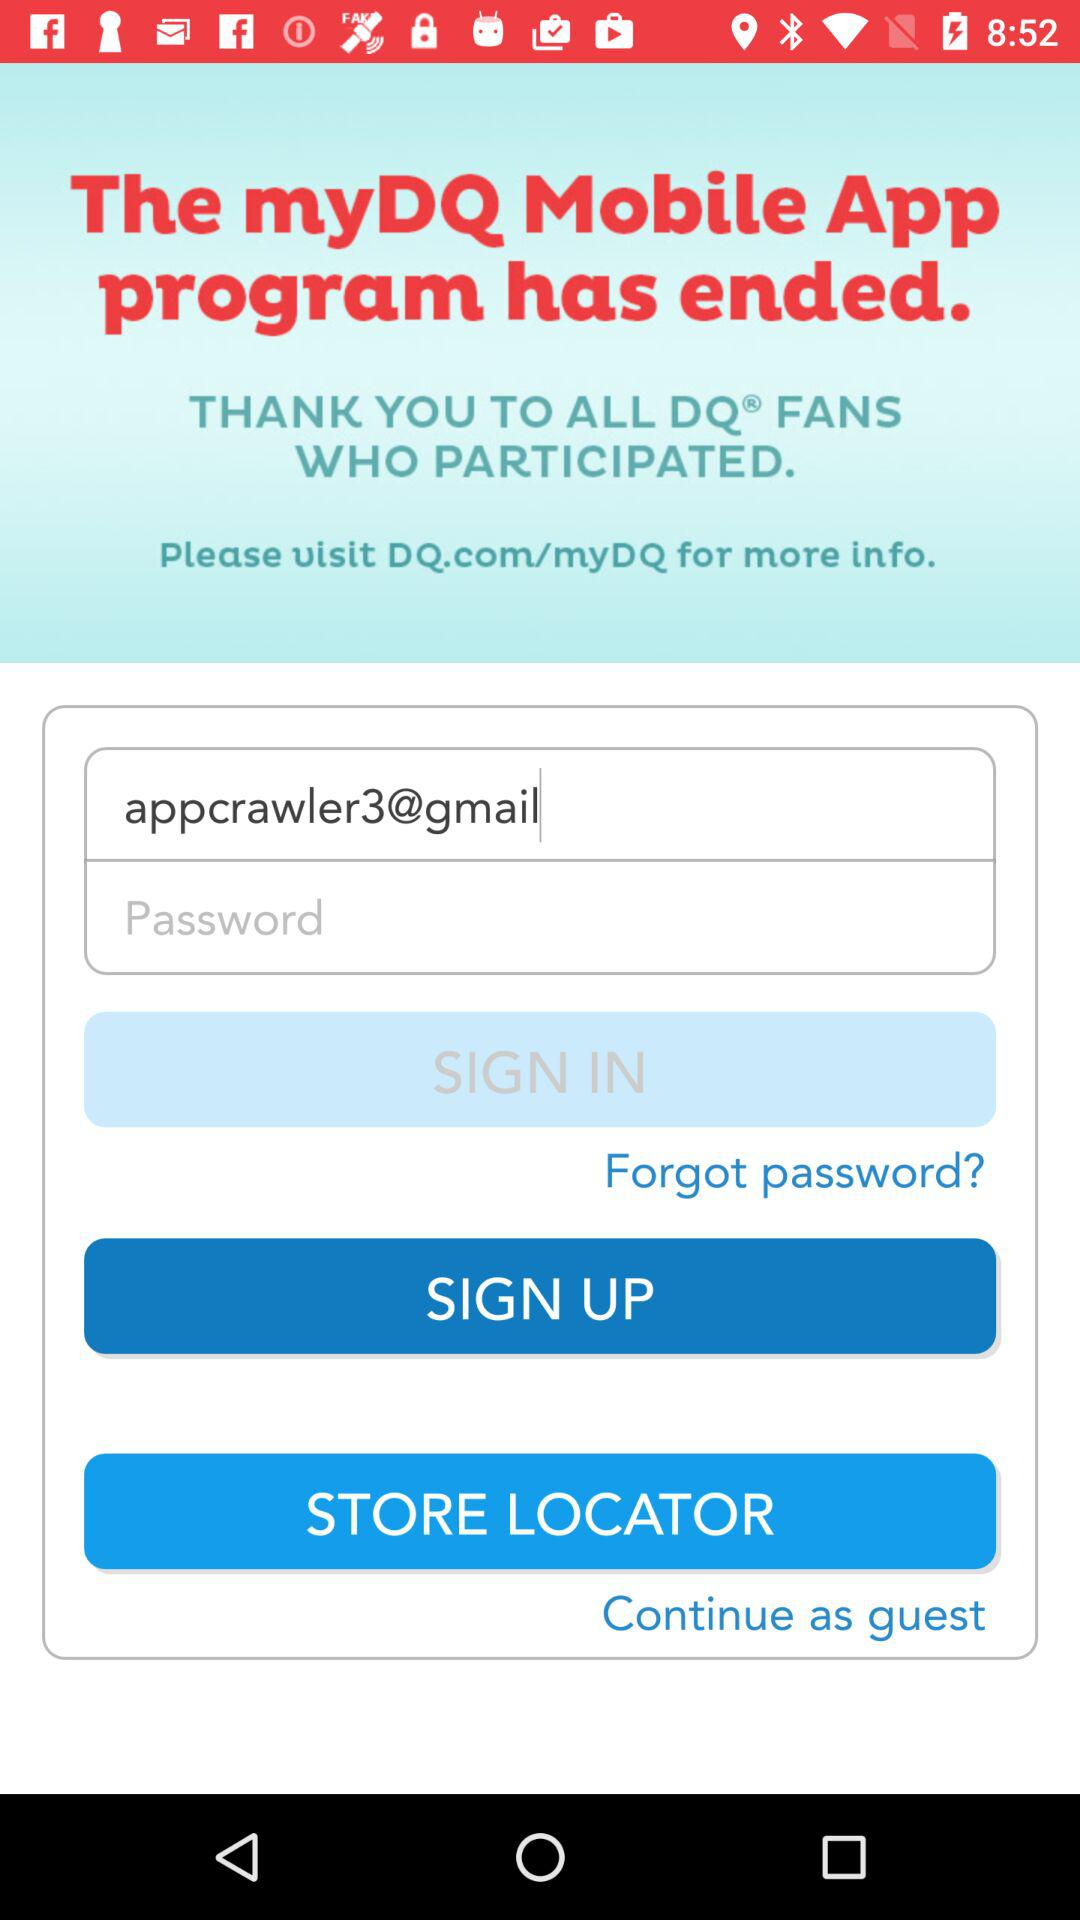What is the entered email address? The entered email address is appcrawler3@gmail.com. 